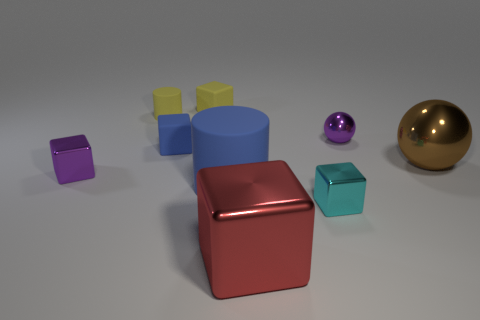Subtract all blue rubber cubes. How many cubes are left? 4 Subtract 3 cubes. How many cubes are left? 2 Subtract all yellow cubes. How many cubes are left? 4 Add 1 brown matte spheres. How many brown matte spheres exist? 1 Subtract 0 brown cylinders. How many objects are left? 9 Subtract all cylinders. How many objects are left? 7 Subtract all blue balls. Subtract all brown cylinders. How many balls are left? 2 Subtract all small cyan cubes. Subtract all big red objects. How many objects are left? 7 Add 6 big rubber objects. How many big rubber objects are left? 7 